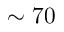Convert formula to latex. <formula><loc_0><loc_0><loc_500><loc_500>\sim 7 0</formula> 